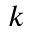Convert formula to latex. <formula><loc_0><loc_0><loc_500><loc_500>k</formula> 